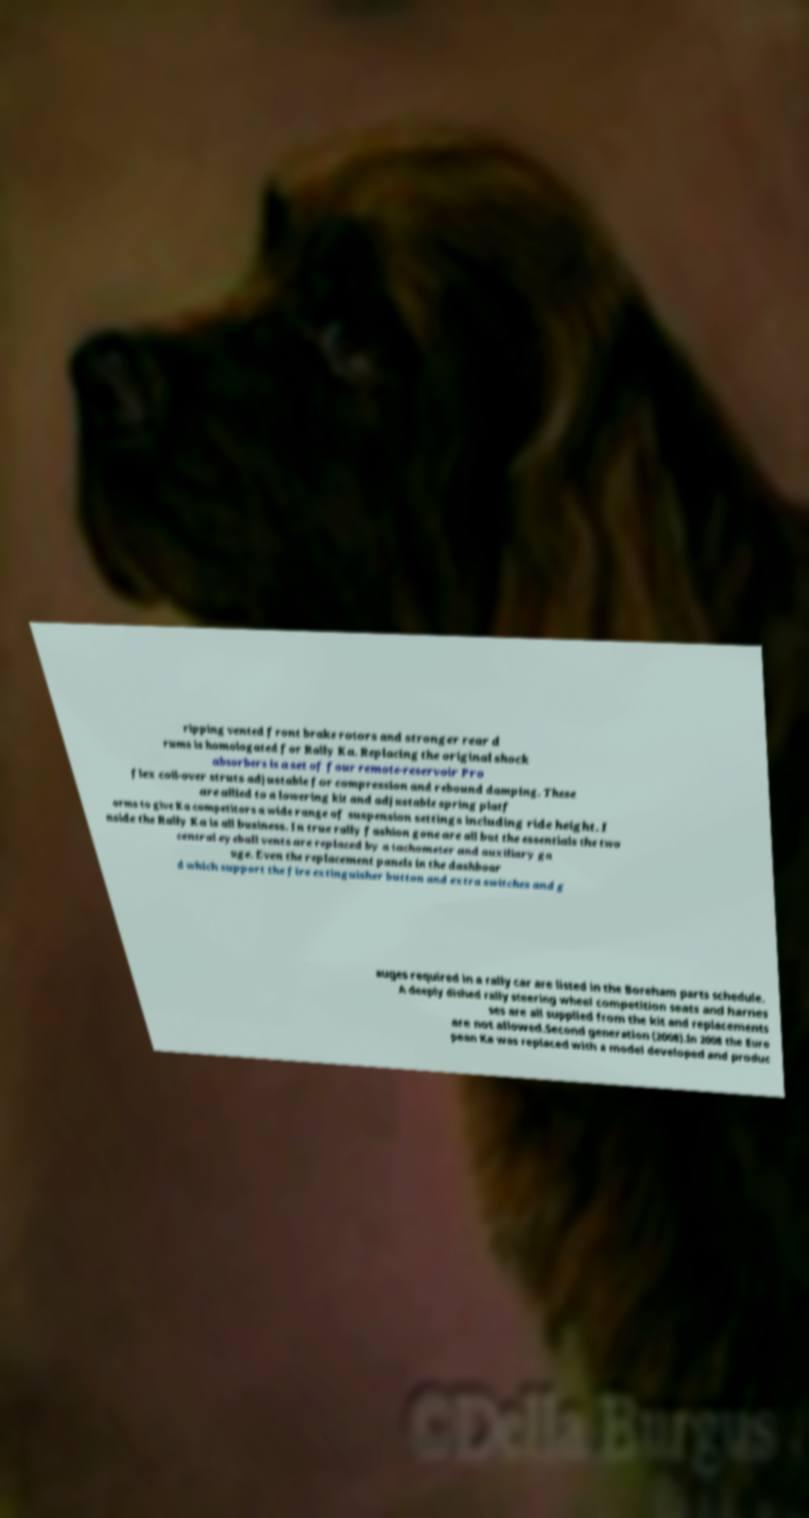For documentation purposes, I need the text within this image transcribed. Could you provide that? ripping vented front brake rotors and stronger rear d rums is homologated for Rally Ka. Replacing the original shock absorbers is a set of four remote-reservoir Pro flex coil-over struts adjustable for compression and rebound damping. These are allied to a lowering kit and adjustable spring platf orms to give Ka competitors a wide range of suspension settings including ride height. I nside the Rally Ka is all business. In true rally fashion gone are all but the essentials the two central eyeball vents are replaced by a tachometer and auxiliary ga uge. Even the replacement panels in the dashboar d which support the fire extinguisher button and extra switches and g auges required in a rally car are listed in the Boreham parts schedule. A deeply dished rally steering wheel competition seats and harnes ses are all supplied from the kit and replacements are not allowed.Second generation (2008).In 2008 the Euro pean Ka was replaced with a model developed and produc 